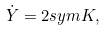Convert formula to latex. <formula><loc_0><loc_0><loc_500><loc_500>\dot { Y } = 2 s y m K ,</formula> 